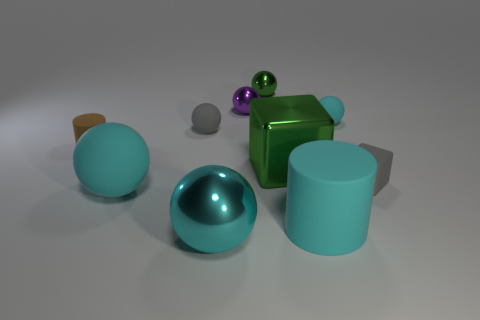Subtract all cyan blocks. How many cyan spheres are left? 3 Subtract all green balls. How many balls are left? 5 Subtract all gray balls. How many balls are left? 5 Subtract all purple balls. Subtract all yellow cubes. How many balls are left? 5 Subtract all cylinders. How many objects are left? 8 Subtract 1 gray balls. How many objects are left? 9 Subtract all metal blocks. Subtract all cyan balls. How many objects are left? 6 Add 3 small green objects. How many small green objects are left? 4 Add 9 tiny blue rubber cylinders. How many tiny blue rubber cylinders exist? 9 